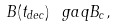<formula> <loc_0><loc_0><loc_500><loc_500>B ( t _ { d e c } ) \ g a q B _ { c } ,</formula> 